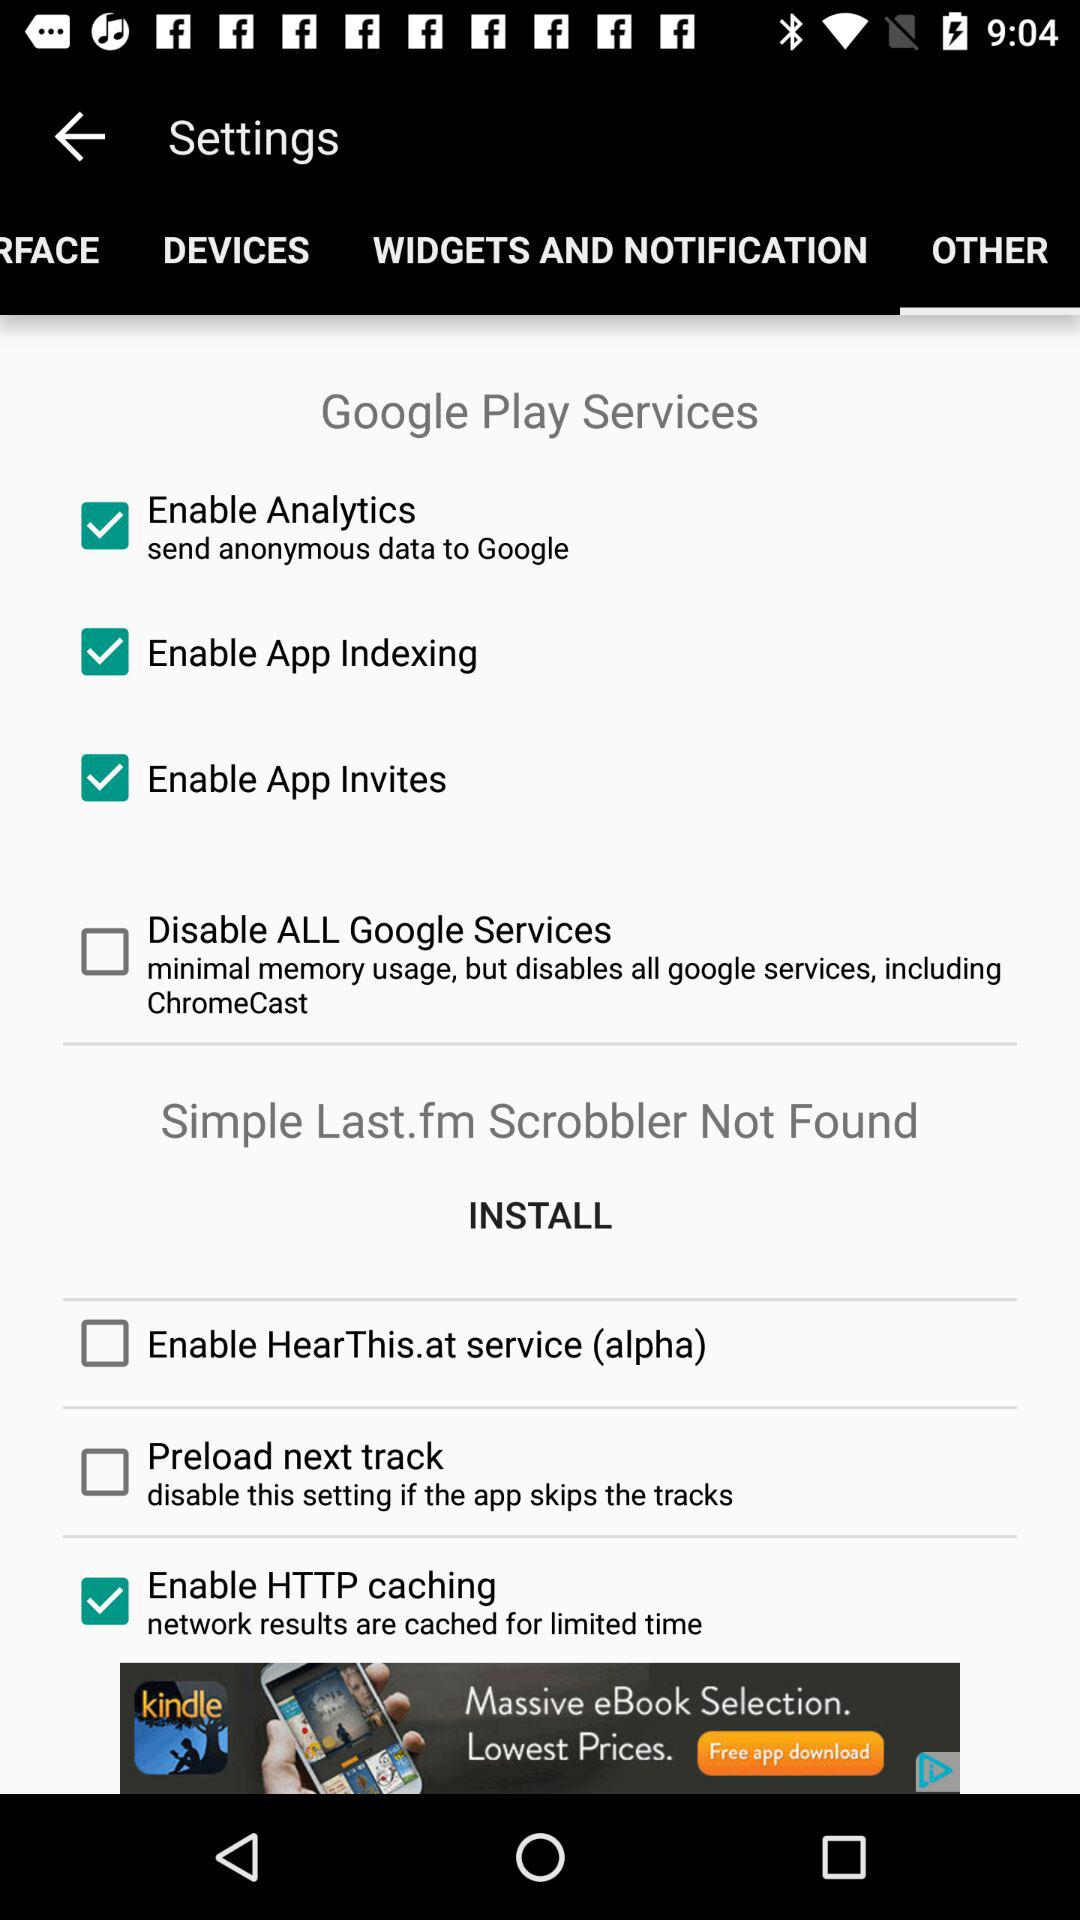What are the selected options? The selected options are "Enable Analytics", "Enable App Indexing", "Enable App Invites" and "Enable HTTP caching". 